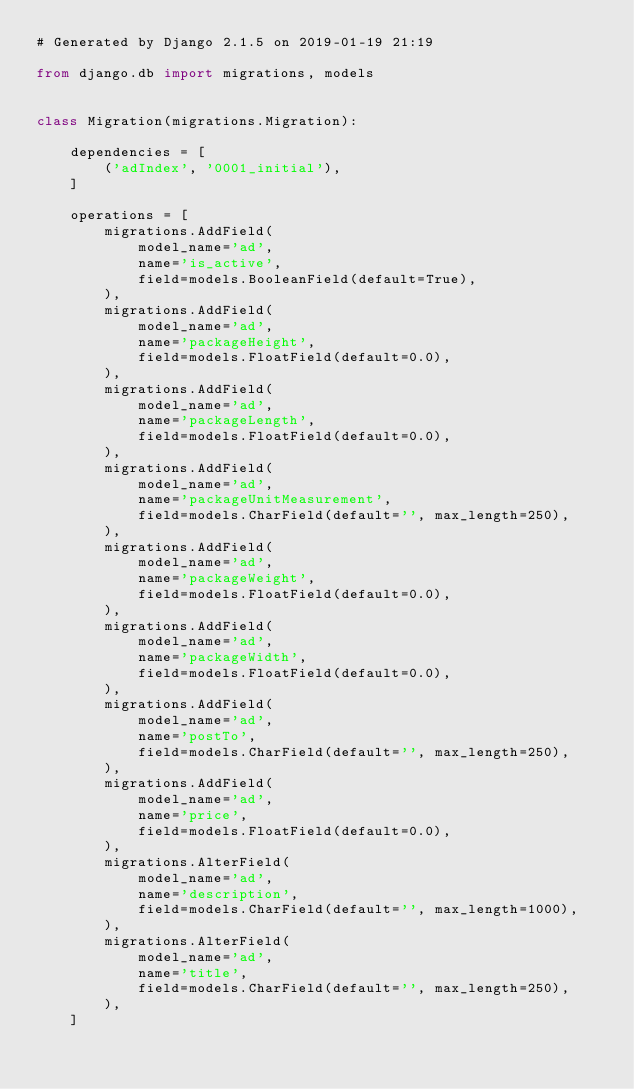Convert code to text. <code><loc_0><loc_0><loc_500><loc_500><_Python_># Generated by Django 2.1.5 on 2019-01-19 21:19

from django.db import migrations, models


class Migration(migrations.Migration):

    dependencies = [
        ('adIndex', '0001_initial'),
    ]

    operations = [
        migrations.AddField(
            model_name='ad',
            name='is_active',
            field=models.BooleanField(default=True),
        ),
        migrations.AddField(
            model_name='ad',
            name='packageHeight',
            field=models.FloatField(default=0.0),
        ),
        migrations.AddField(
            model_name='ad',
            name='packageLength',
            field=models.FloatField(default=0.0),
        ),
        migrations.AddField(
            model_name='ad',
            name='packageUnitMeasurement',
            field=models.CharField(default='', max_length=250),
        ),
        migrations.AddField(
            model_name='ad',
            name='packageWeight',
            field=models.FloatField(default=0.0),
        ),
        migrations.AddField(
            model_name='ad',
            name='packageWidth',
            field=models.FloatField(default=0.0),
        ),
        migrations.AddField(
            model_name='ad',
            name='postTo',
            field=models.CharField(default='', max_length=250),
        ),
        migrations.AddField(
            model_name='ad',
            name='price',
            field=models.FloatField(default=0.0),
        ),
        migrations.AlterField(
            model_name='ad',
            name='description',
            field=models.CharField(default='', max_length=1000),
        ),
        migrations.AlterField(
            model_name='ad',
            name='title',
            field=models.CharField(default='', max_length=250),
        ),
    ]
</code> 